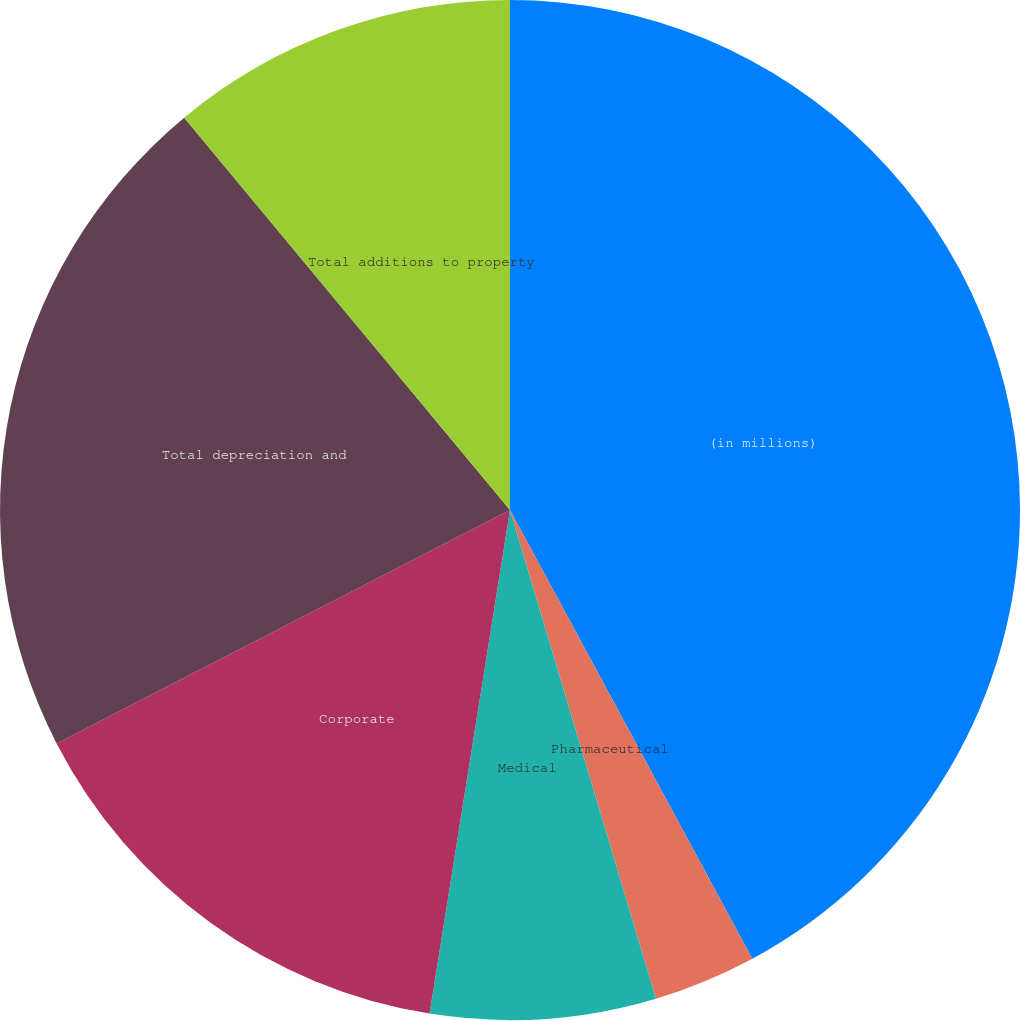Convert chart to OTSL. <chart><loc_0><loc_0><loc_500><loc_500><pie_chart><fcel>(in millions)<fcel>Pharmaceutical<fcel>Medical<fcel>Corporate<fcel>Total depreciation and<fcel>Total additions to property<nl><fcel>42.12%<fcel>3.26%<fcel>7.14%<fcel>14.91%<fcel>21.54%<fcel>11.03%<nl></chart> 